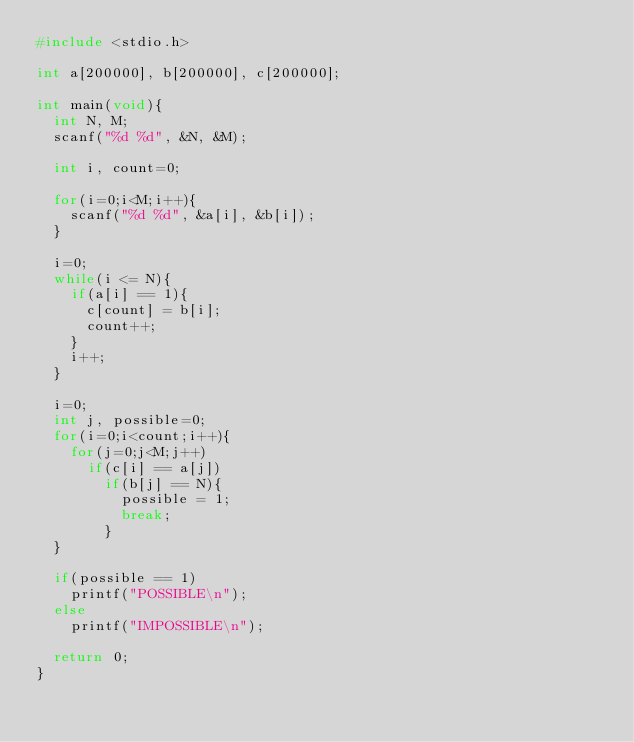Convert code to text. <code><loc_0><loc_0><loc_500><loc_500><_C_>#include <stdio.h>

int a[200000], b[200000], c[200000];

int main(void){
  int N, M;
  scanf("%d %d", &N, &M);

  int i, count=0;

  for(i=0;i<M;i++){
    scanf("%d %d", &a[i], &b[i]);
  }

  i=0;
  while(i <= N){
    if(a[i] == 1){
      c[count] = b[i];
      count++;
    }
    i++;
  }

  i=0;
  int j, possible=0;
  for(i=0;i<count;i++){
    for(j=0;j<M;j++)
      if(c[i] == a[j])
        if(b[j] == N){
          possible = 1;
          break;
        }
  }

  if(possible == 1)
    printf("POSSIBLE\n");
  else
    printf("IMPOSSIBLE\n");

  return 0;
}
</code> 